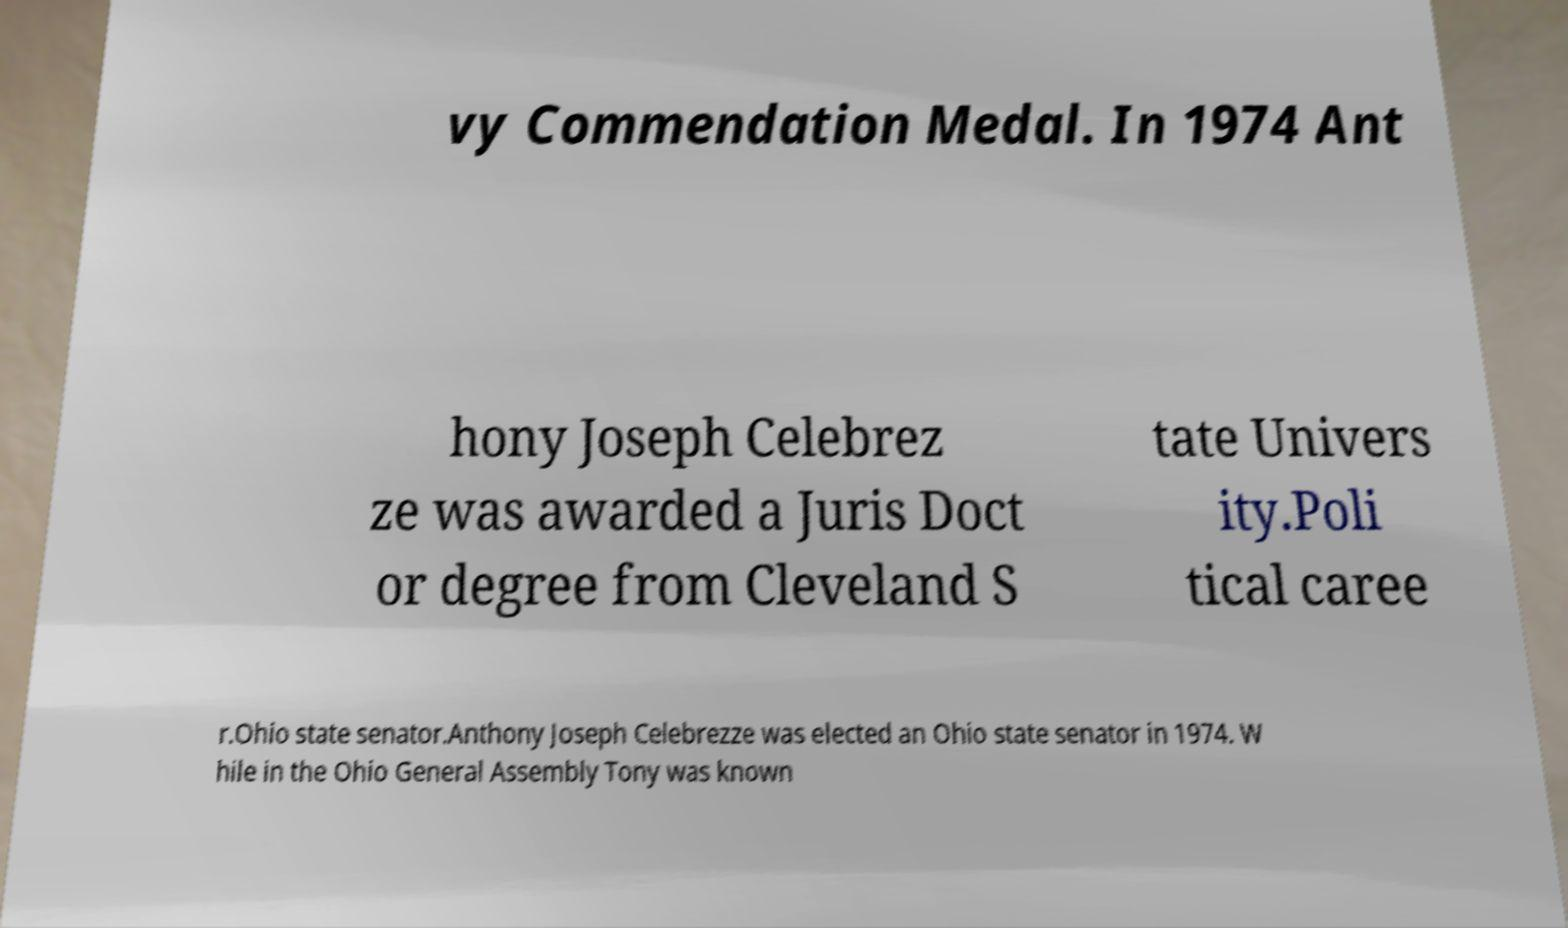Can you accurately transcribe the text from the provided image for me? vy Commendation Medal. In 1974 Ant hony Joseph Celebrez ze was awarded a Juris Doct or degree from Cleveland S tate Univers ity.Poli tical caree r.Ohio state senator.Anthony Joseph Celebrezze was elected an Ohio state senator in 1974. W hile in the Ohio General Assembly Tony was known 